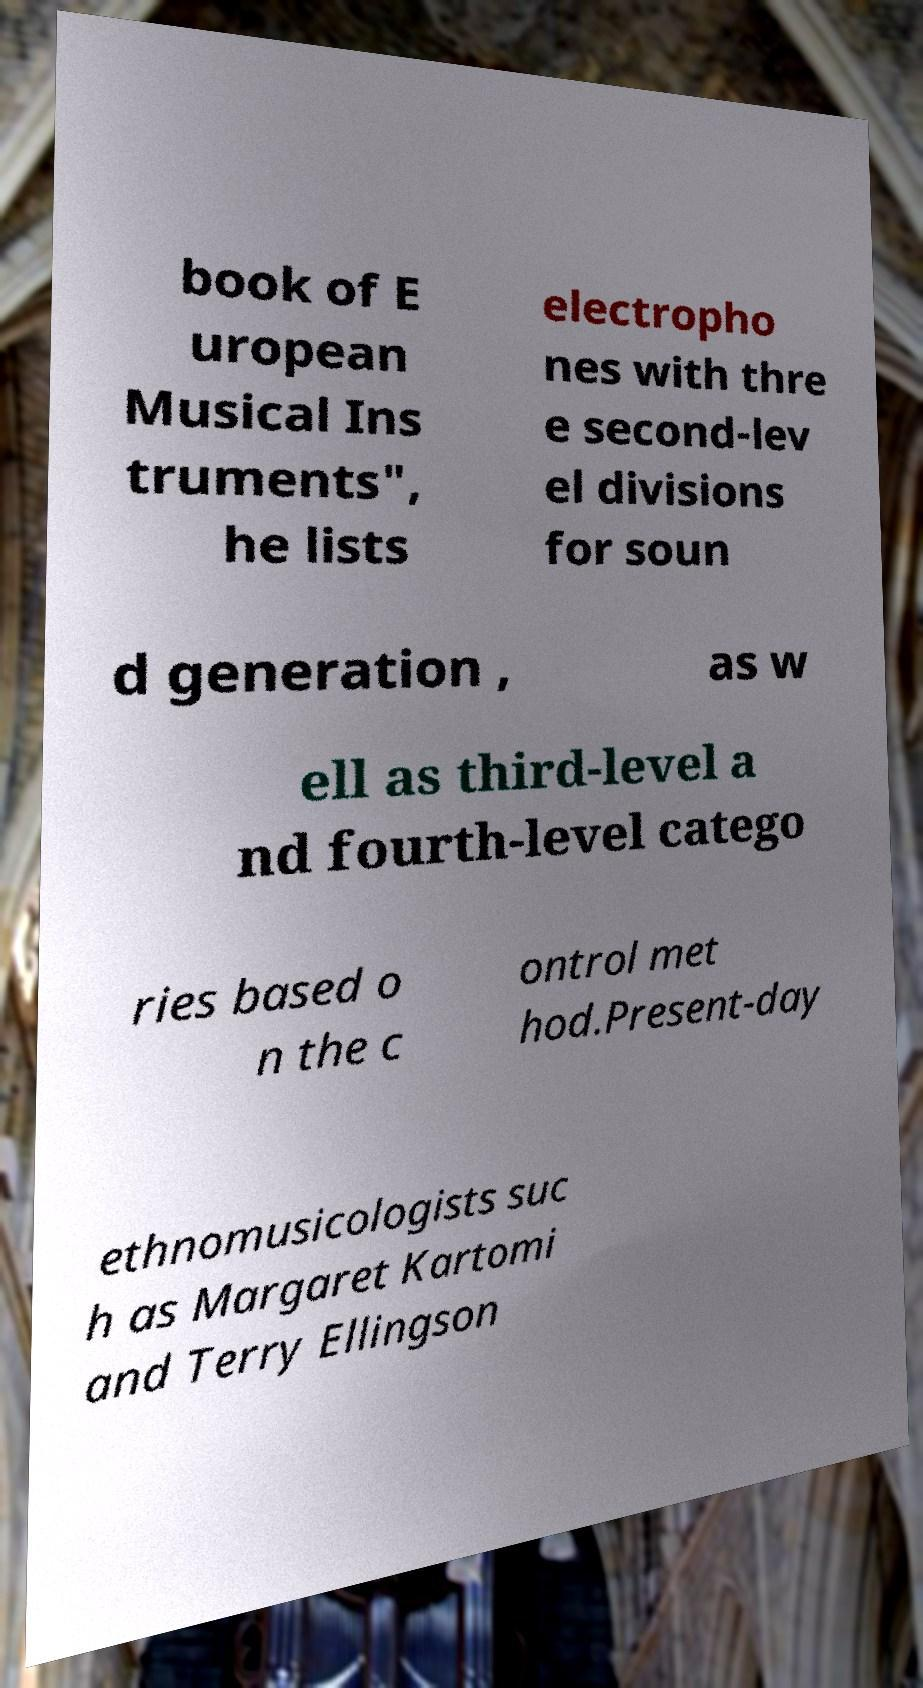What messages or text are displayed in this image? I need them in a readable, typed format. book of E uropean Musical Ins truments", he lists electropho nes with thre e second-lev el divisions for soun d generation , as w ell as third-level a nd fourth-level catego ries based o n the c ontrol met hod.Present-day ethnomusicologists suc h as Margaret Kartomi and Terry Ellingson 